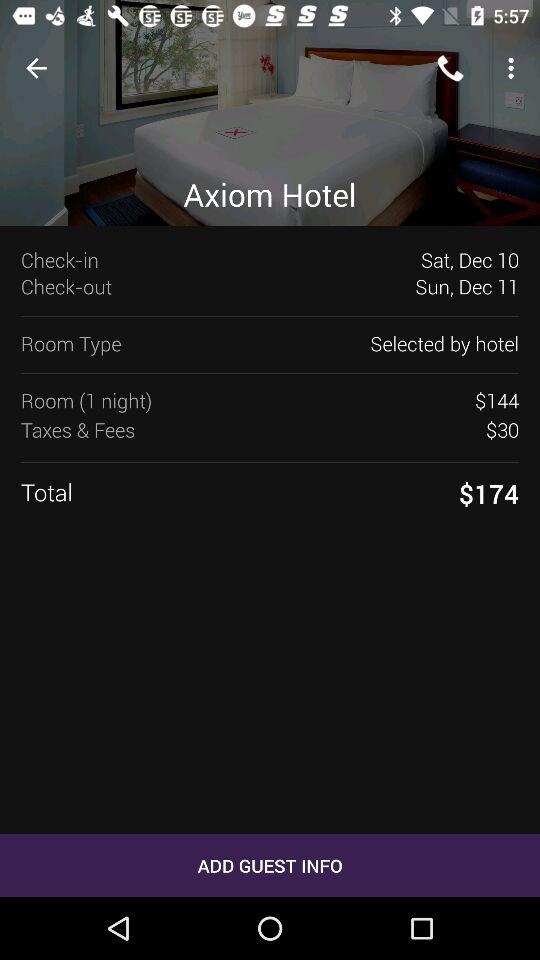What is the total amount? The total amount is $174. 